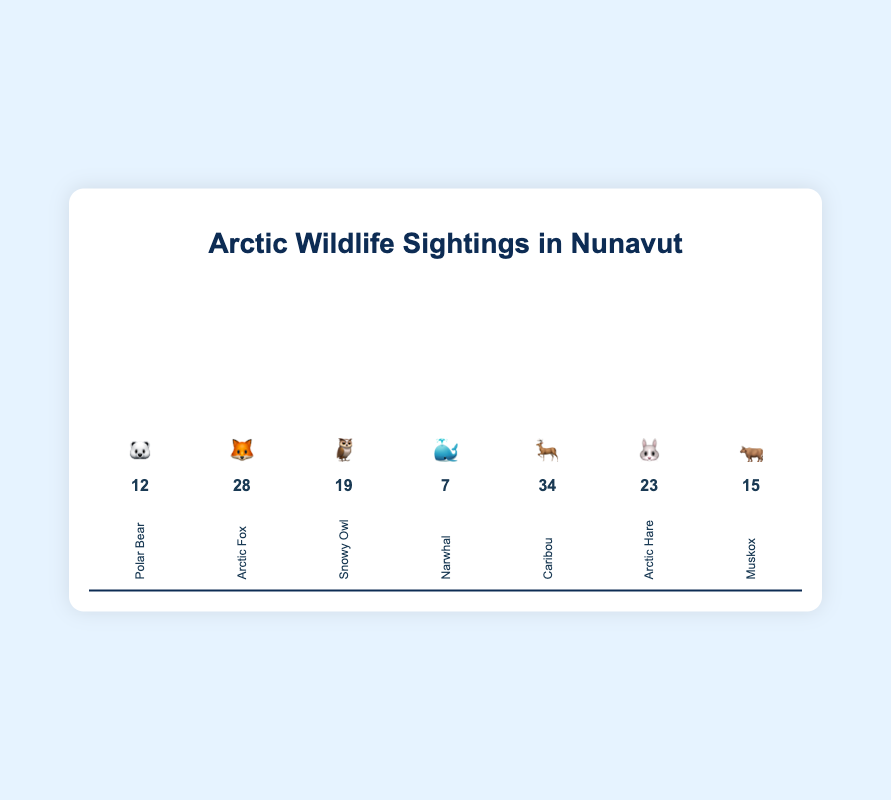What's the title of the chart? The title of the chart is displayed prominently at the top in a larger font.
Answer: Arctic Wildlife Sightings in Nunavut How many sightings of the 🦌 Caribou have been recorded? The number of sightings is provided directly below the Caribou emoji in the figure.
Answer: 34 Which species has the fewest sightings and how many? We need to compare the number of sightings for all species and identify the lowest value. The species with the fewest sightings is the 🐳 Narwhal with 7 sightings.
Answer: 🐳 Narwhal, 7 What is the combined total of sightings for 🦊 Arctic Fox and 🦉 Snowy Owl? Add the sighting numbers for Arctic Fox (28) and Snowy Owl (19). 28 + 19 = 47
Answer: 47 Which species' bar is the highest and why? The highest bar represents the species with the most sightings. Comparing the bars, the 🦌 Caribou bar is the tallest, meaning it has the most sightings.
Answer: 🦌 Caribou How many more sightings does the 🦌 Caribou have compared to the 🐻‍❄️ Polar Bear? Subtract the Polar Bear sightings (12) from the Caribou sightings (34). 34 - 12 = 22
Answer: 22 Rank the species from most to least sightings using their emojis. List the species in descending order based on their number of sightings. From most to least: 🦌, 🦊, 🐰, 🦉, 🐂, 🐻‍❄️, 🐳.
Answer: 🦌 > 🦊 > 🐰 > 🦉 > 🐂 > 🐻‍❄️ > 🐳 What percentage of the total sightings does the 🐂 Muskox represent? Calculate the sum of all sightings: 12 + 28 + 19 + 7 + 34 + 23 + 15 = 138. Then, find the percentage for the Muskox: (15 / 138) * 100%. The calculation is about 10.87%.
Answer: 10.87% Which two species have the closest number of sightings, and what is the difference? Compare all counts to find the smallest difference. 🦉 Snowy Owl (19) and 🐂 Muskox (15) have a difference of 4 sightings. 19 - 15 = 4
Answer: 🦉 and 🐂, 4 How many bars in the chart are taller than half-way? Identify which bars in the chart exceed 50% height. The species with sightings above half-way (more than 17 sightings) are 🦊 Arctic Fox, 🦌 Caribou, and 🐰 Arctic Hare. Thus, there are 3 bars.
Answer: 3 